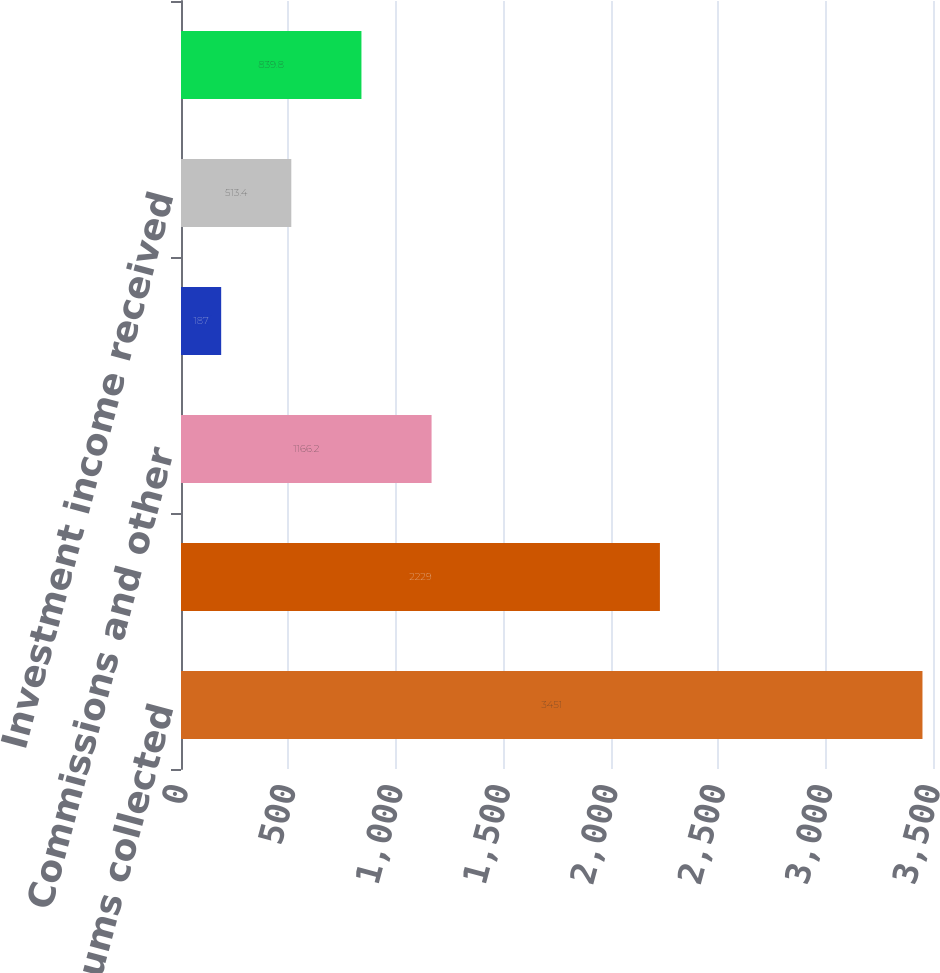<chart> <loc_0><loc_0><loc_500><loc_500><bar_chart><fcel>Premiums collected<fcel>Loss and loss expenses paid<fcel>Commissions and other<fcel>Cash flow from underwriting<fcel>Investment income received<fcel>Cash flow from operating<nl><fcel>3451<fcel>2229<fcel>1166.2<fcel>187<fcel>513.4<fcel>839.8<nl></chart> 